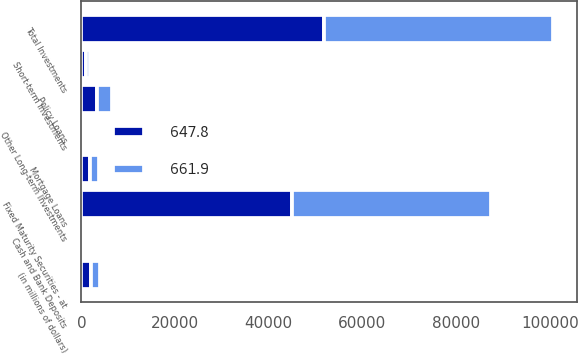Convert chart to OTSL. <chart><loc_0><loc_0><loc_500><loc_500><stacked_bar_chart><ecel><fcel>(in millions of dollars)<fcel>Fixed Maturity Securities - at<fcel>Mortgage Loans<fcel>Policy Loans<fcel>Other Long-term Investments<fcel>Short-term Investments<fcel>Total Investments<fcel>Cash and Bank Deposits<nl><fcel>647.8<fcel>2014<fcel>45064.9<fcel>1856.6<fcel>3306.6<fcel>591.9<fcel>974.3<fcel>51794.3<fcel>102.5<nl><fcel>661.9<fcel>2013<fcel>42344.4<fcel>1815.1<fcel>3276<fcel>566<fcel>913.4<fcel>48914.9<fcel>94.1<nl></chart> 